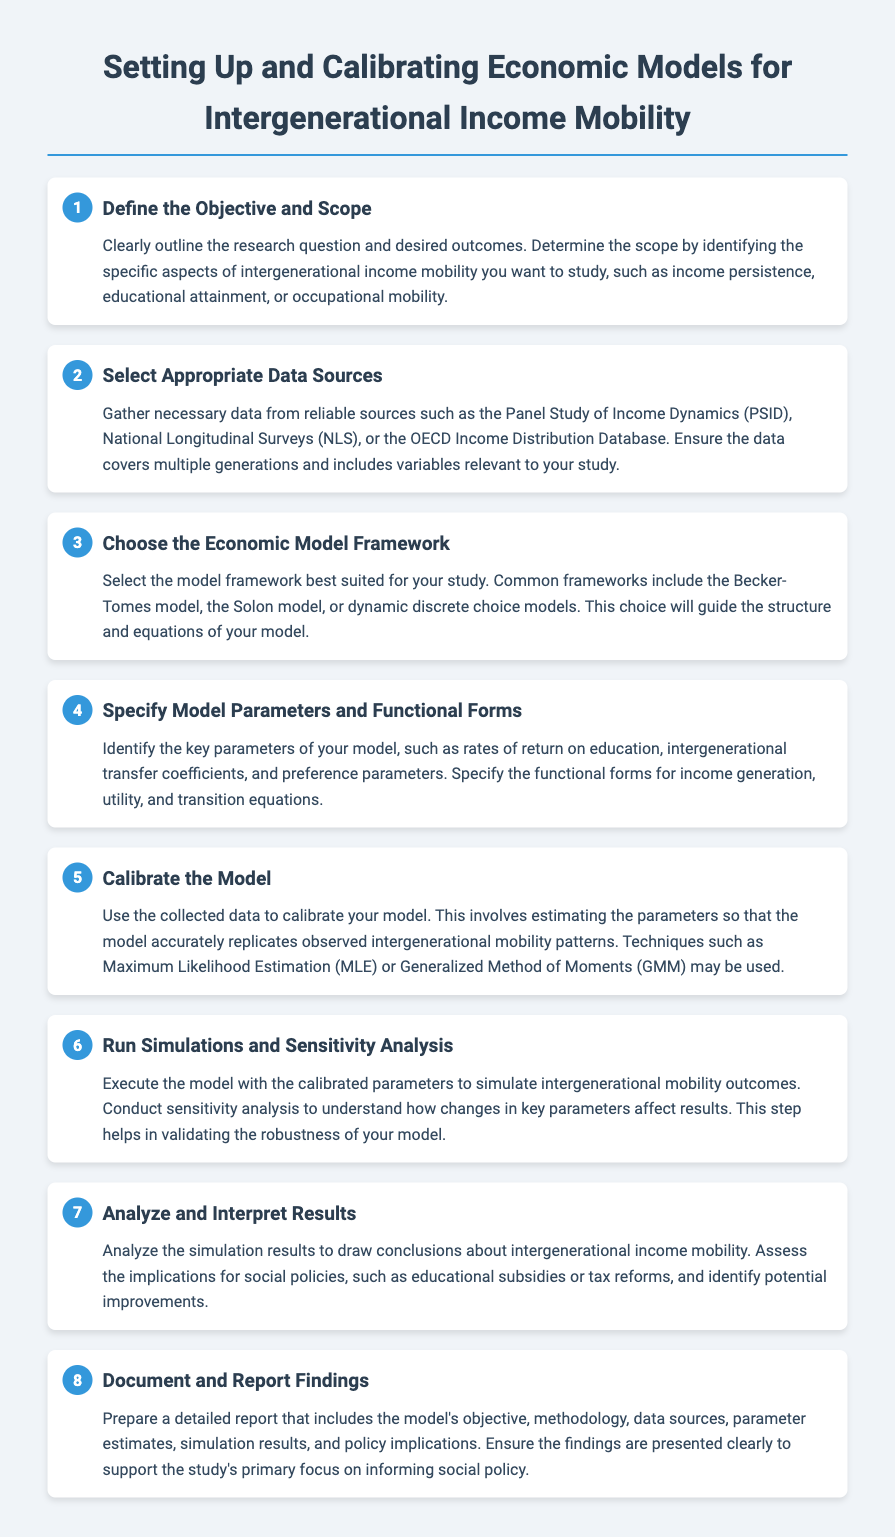What is the primary objective of the document? The document outlines a step-by-step procedure for setting up and calibrating economic models to study intergenerational income mobility.
Answer: Setting up and calibrating economic models What is the first step in the procedure? The first step involves clearly outlining the research question and desired outcomes regarding intergenerational income mobility.
Answer: Define the Objective and Scope Which data source is mentioned for gathering necessary data? The document mentions several sources, including the Panel Study of Income Dynamics (PSID).
Answer: Panel Study of Income Dynamics How many steps are outlined in the procedure? The document contains a total of eight steps for setting up and calibrating economic models.
Answer: Eight What is involved in the calibration of the model? Calibration involves estimating the parameters so that the model accurately replicates observed intergenerational mobility patterns.
Answer: Estimating parameters What kind of analysis is performed after running simulations? The document specifies conducting a sensitivity analysis to understand how changes in key parameters affect results.
Answer: Sensitivity analysis What does the last step emphasize in the documentation process? The last step emphasizes preparing a detailed report that includes findings and implications for social policy.
Answer: Document and Report Findings Which economic model frameworks are suggested in the document? The document mentions some frameworks like the Becker-Tomes model and the Solon model.
Answer: Becker-Tomes model, Solon model 